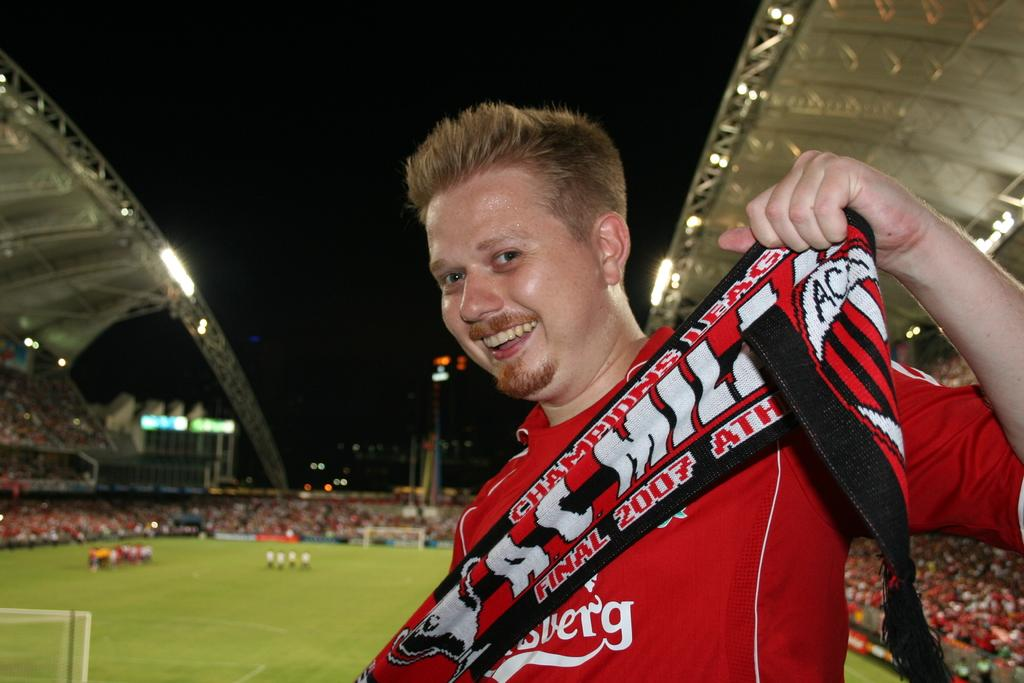Provide a one-sentence caption for the provided image. Man at a football game showing off his shirt that says "Final 2007". 